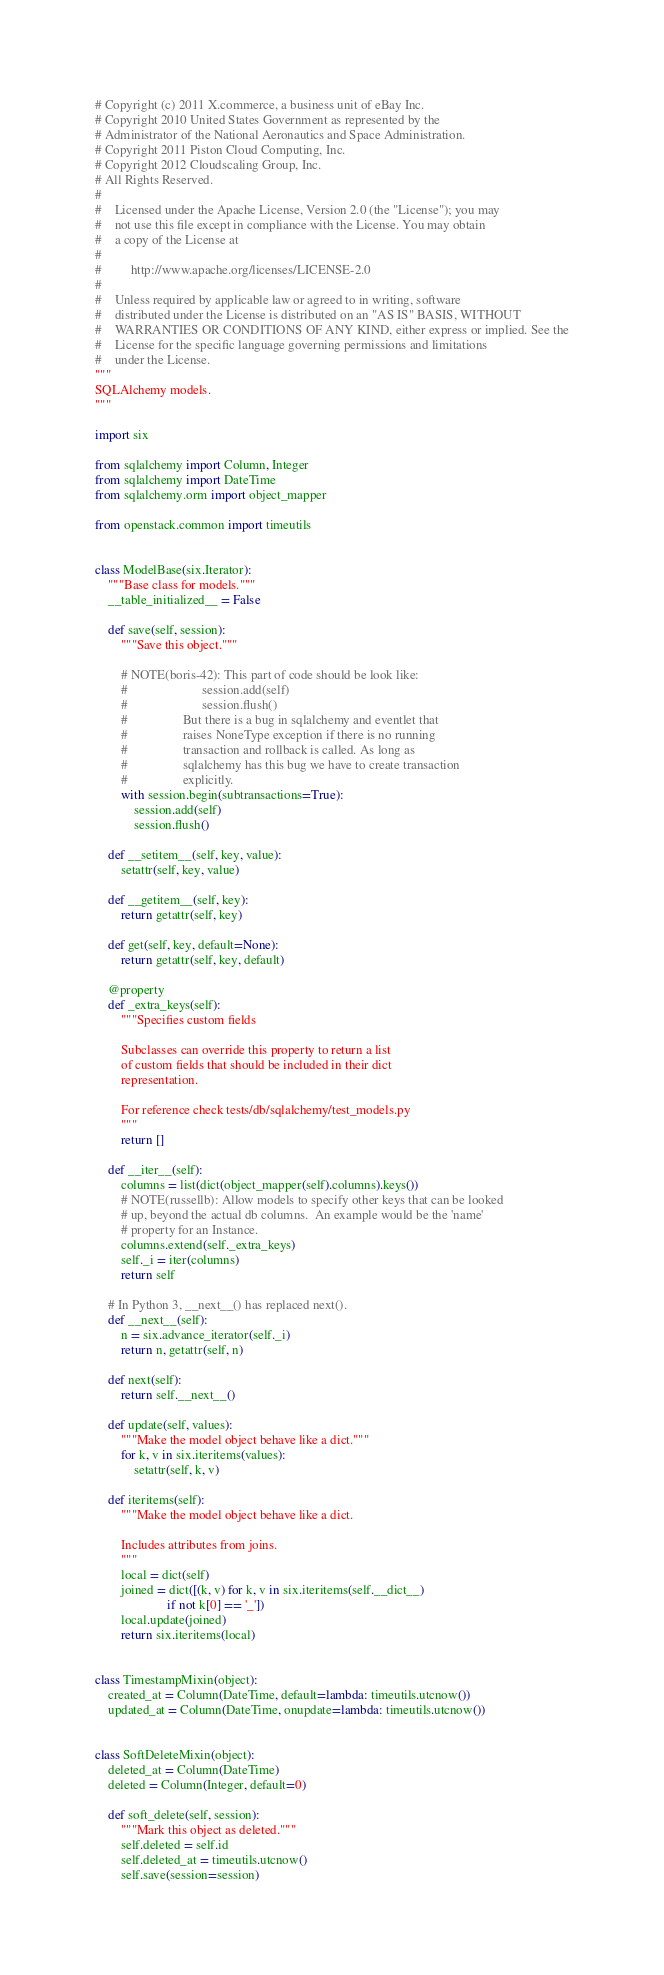<code> <loc_0><loc_0><loc_500><loc_500><_Python_># Copyright (c) 2011 X.commerce, a business unit of eBay Inc.
# Copyright 2010 United States Government as represented by the
# Administrator of the National Aeronautics and Space Administration.
# Copyright 2011 Piston Cloud Computing, Inc.
# Copyright 2012 Cloudscaling Group, Inc.
# All Rights Reserved.
#
#    Licensed under the Apache License, Version 2.0 (the "License"); you may
#    not use this file except in compliance with the License. You may obtain
#    a copy of the License at
#
#         http://www.apache.org/licenses/LICENSE-2.0
#
#    Unless required by applicable law or agreed to in writing, software
#    distributed under the License is distributed on an "AS IS" BASIS, WITHOUT
#    WARRANTIES OR CONDITIONS OF ANY KIND, either express or implied. See the
#    License for the specific language governing permissions and limitations
#    under the License.
"""
SQLAlchemy models.
"""

import six

from sqlalchemy import Column, Integer
from sqlalchemy import DateTime
from sqlalchemy.orm import object_mapper

from openstack.common import timeutils


class ModelBase(six.Iterator):
    """Base class for models."""
    __table_initialized__ = False

    def save(self, session):
        """Save this object."""

        # NOTE(boris-42): This part of code should be look like:
        #                       session.add(self)
        #                       session.flush()
        #                 But there is a bug in sqlalchemy and eventlet that
        #                 raises NoneType exception if there is no running
        #                 transaction and rollback is called. As long as
        #                 sqlalchemy has this bug we have to create transaction
        #                 explicitly.
        with session.begin(subtransactions=True):
            session.add(self)
            session.flush()

    def __setitem__(self, key, value):
        setattr(self, key, value)

    def __getitem__(self, key):
        return getattr(self, key)

    def get(self, key, default=None):
        return getattr(self, key, default)

    @property
    def _extra_keys(self):
        """Specifies custom fields

        Subclasses can override this property to return a list
        of custom fields that should be included in their dict
        representation.

        For reference check tests/db/sqlalchemy/test_models.py
        """
        return []

    def __iter__(self):
        columns = list(dict(object_mapper(self).columns).keys())
        # NOTE(russellb): Allow models to specify other keys that can be looked
        # up, beyond the actual db columns.  An example would be the 'name'
        # property for an Instance.
        columns.extend(self._extra_keys)
        self._i = iter(columns)
        return self

    # In Python 3, __next__() has replaced next().
    def __next__(self):
        n = six.advance_iterator(self._i)
        return n, getattr(self, n)

    def next(self):
        return self.__next__()

    def update(self, values):
        """Make the model object behave like a dict."""
        for k, v in six.iteritems(values):
            setattr(self, k, v)

    def iteritems(self):
        """Make the model object behave like a dict.

        Includes attributes from joins.
        """
        local = dict(self)
        joined = dict([(k, v) for k, v in six.iteritems(self.__dict__)
                      if not k[0] == '_'])
        local.update(joined)
        return six.iteritems(local)


class TimestampMixin(object):
    created_at = Column(DateTime, default=lambda: timeutils.utcnow())
    updated_at = Column(DateTime, onupdate=lambda: timeutils.utcnow())


class SoftDeleteMixin(object):
    deleted_at = Column(DateTime)
    deleted = Column(Integer, default=0)

    def soft_delete(self, session):
        """Mark this object as deleted."""
        self.deleted = self.id
        self.deleted_at = timeutils.utcnow()
        self.save(session=session)
</code> 